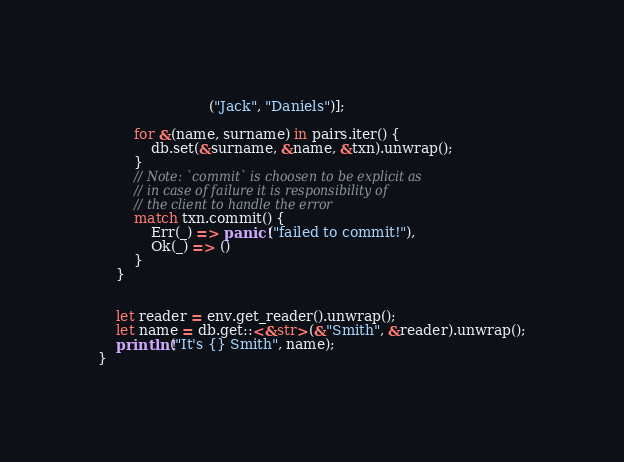<code> <loc_0><loc_0><loc_500><loc_500><_Rust_>                         ("Jack", "Daniels")];

        for &(name, surname) in pairs.iter() {
            db.set(&surname, &name, &txn).unwrap();
        }
        // Note: `commit` is choosen to be explicit as
        // in case of failure it is responsibility of
        // the client to handle the error
        match txn.commit() {
            Err(_) => panic!("failed to commit!"),
            Ok(_) => ()
        }
    }


    let reader = env.get_reader().unwrap();
    let name = db.get::<&str>(&"Smith", &reader).unwrap();
    println!("It's {} Smith", name);
}
</code> 